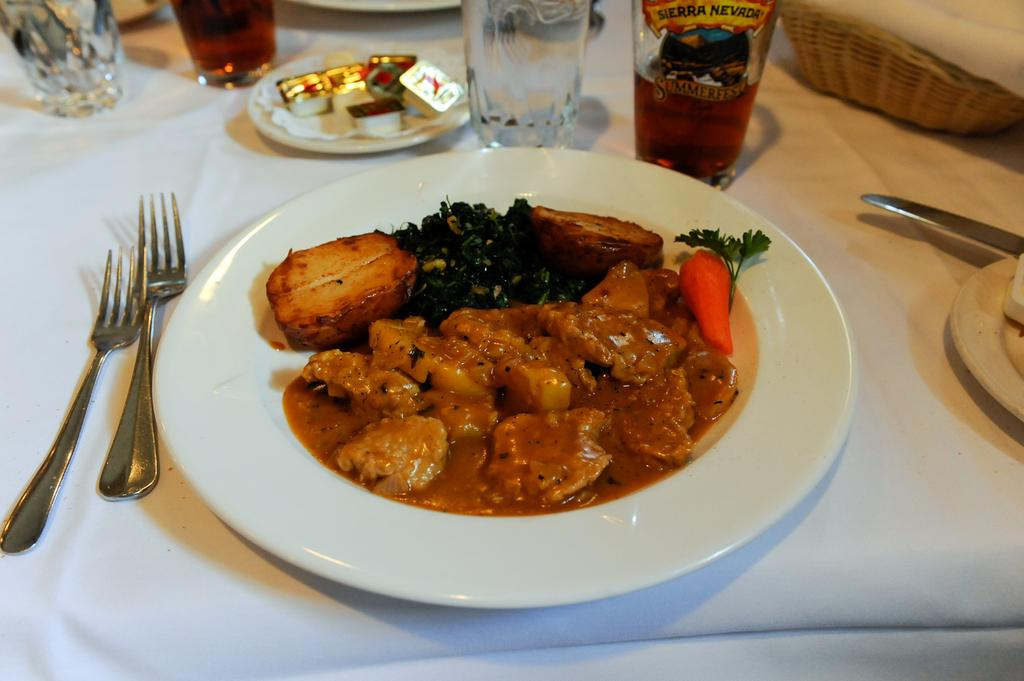What type of food is on the plates in the image? The specific type of food cannot be determined from the image, but there are plates with food in the image. What can be found in the glasses in the image? There are glasses with drinks in the image. What utensils are visible in the image? There are forks and knives in the image. What is the color of the surface the items are on? The surface the items are on is white in color. Can you see a donkey eating food from the plates in the image? No, there is no donkey present in the image, and the food is on the plates, not being eaten by an animal. 